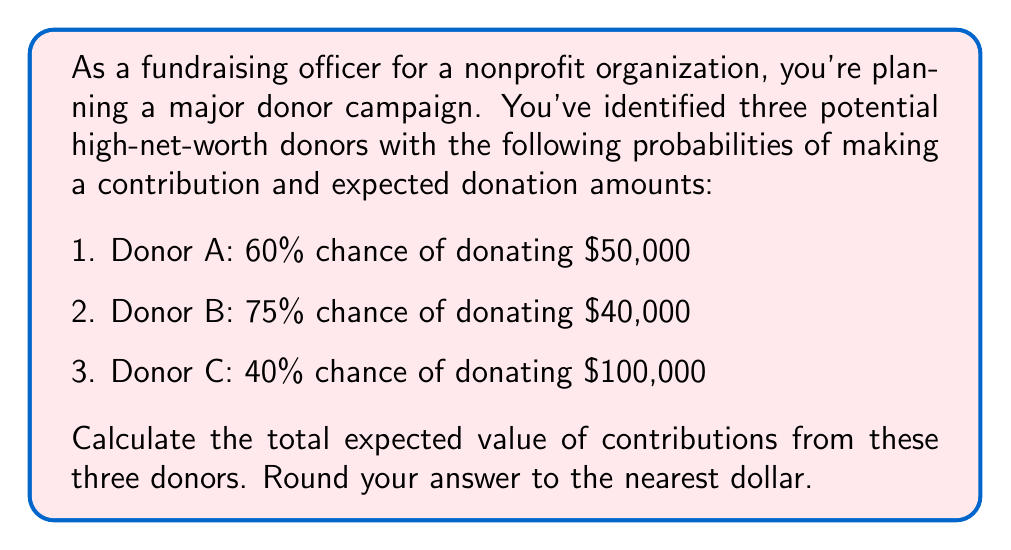Help me with this question. To solve this problem, we need to calculate the expected value of each donor's contribution and then sum them up. The expected value is calculated by multiplying the probability of the event occurring by the value of the event.

Let's calculate the expected value for each donor:

1. Donor A:
   Probability = 60% = 0.60
   Donation amount = $50,000
   Expected value = $50,000 \times 0.60 = $30,000

2. Donor B:
   Probability = 75% = 0.75
   Donation amount = $40,000
   Expected value = $40,000 \times 0.75 = $30,000

3. Donor C:
   Probability = 40% = 0.40
   Donation amount = $100,000
   Expected value = $100,000 \times 0.40 = $40,000

Now, we sum up the expected values from all three donors:

Total expected value = $30,000 + $30,000 + $40,000 = $100,000

Therefore, the total expected value of contributions from these three donors is $100,000.

This can be represented mathematically as:

$$\text{Total Expected Value} = \sum_{i=1}^{n} P(D_i) \times A(D_i)$$

Where:
$n$ is the number of donors
$P(D_i)$ is the probability of donor $i$ making a contribution
$A(D_i)$ is the amount of the potential contribution from donor $i$

In this case:

$$\text{Total Expected Value} = (0.60 \times 50000) + (0.75 \times 40000) + (0.40 \times 100000) = 100000$$
Answer: $100,000 